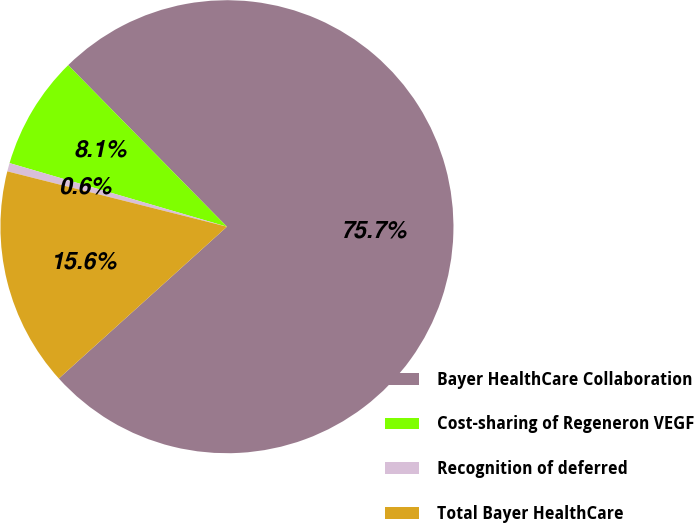<chart> <loc_0><loc_0><loc_500><loc_500><pie_chart><fcel>Bayer HealthCare Collaboration<fcel>Cost-sharing of Regeneron VEGF<fcel>Recognition of deferred<fcel>Total Bayer HealthCare<nl><fcel>75.68%<fcel>8.11%<fcel>0.6%<fcel>15.62%<nl></chart> 